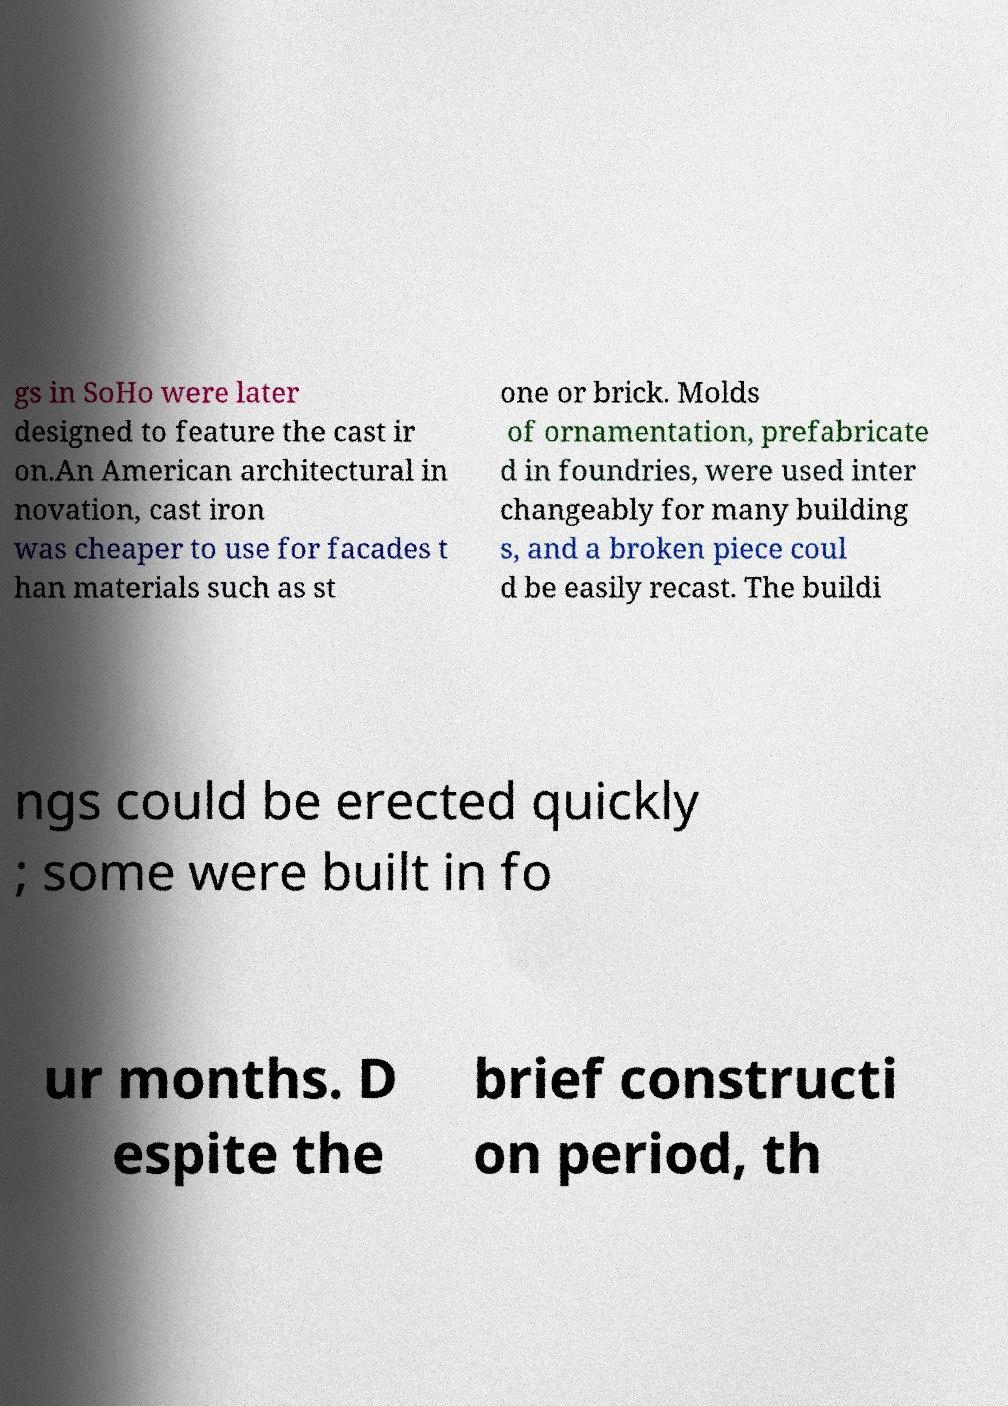I need the written content from this picture converted into text. Can you do that? gs in SoHo were later designed to feature the cast ir on.An American architectural in novation, cast iron was cheaper to use for facades t han materials such as st one or brick. Molds of ornamentation, prefabricate d in foundries, were used inter changeably for many building s, and a broken piece coul d be easily recast. The buildi ngs could be erected quickly ; some were built in fo ur months. D espite the brief constructi on period, th 